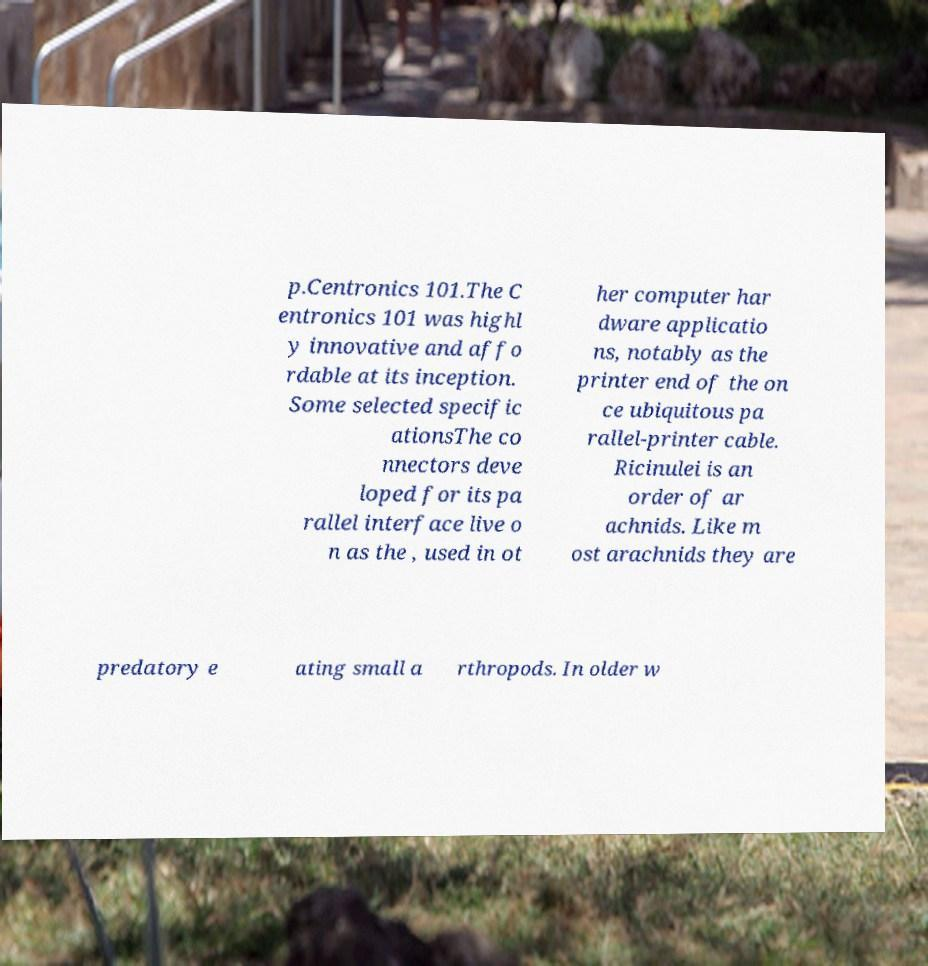I need the written content from this picture converted into text. Can you do that? p.Centronics 101.The C entronics 101 was highl y innovative and affo rdable at its inception. Some selected specific ationsThe co nnectors deve loped for its pa rallel interface live o n as the , used in ot her computer har dware applicatio ns, notably as the printer end of the on ce ubiquitous pa rallel-printer cable. Ricinulei is an order of ar achnids. Like m ost arachnids they are predatory e ating small a rthropods. In older w 